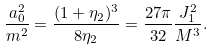<formula> <loc_0><loc_0><loc_500><loc_500>\frac { a _ { 0 } ^ { 2 } } { m ^ { 2 } } = \frac { ( 1 + \eta _ { 2 } ) ^ { 3 } } { 8 \eta _ { 2 } } = \frac { 2 7 \pi } { 3 2 } \frac { J _ { 1 } ^ { 2 } } { M ^ { 3 } } .</formula> 